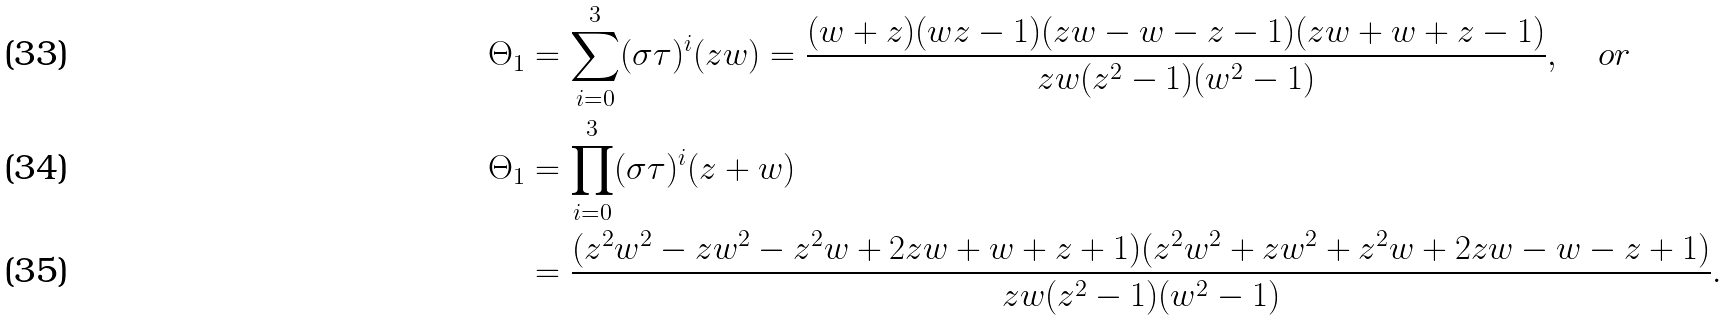Convert formula to latex. <formula><loc_0><loc_0><loc_500><loc_500>\Theta _ { 1 } & = \sum _ { i = 0 } ^ { 3 } ( \sigma \tau ) ^ { i } ( z w ) = \frac { ( w + z ) ( w z - 1 ) ( z w - w - z - 1 ) ( z w + w + z - 1 ) } { z w ( z ^ { 2 } - 1 ) ( w ^ { 2 } - 1 ) } , \quad o r \\ \Theta _ { 1 } & = \prod _ { i = 0 } ^ { 3 } ( \sigma \tau ) ^ { i } ( z + w ) \\ & = \frac { ( z ^ { 2 } w ^ { 2 } - z w ^ { 2 } - z ^ { 2 } w + 2 z w + w + z + 1 ) ( z ^ { 2 } w ^ { 2 } + z w ^ { 2 } + z ^ { 2 } w + 2 z w - w - z + 1 ) } { z w ( z ^ { 2 } - 1 ) ( w ^ { 2 } - 1 ) } .</formula> 